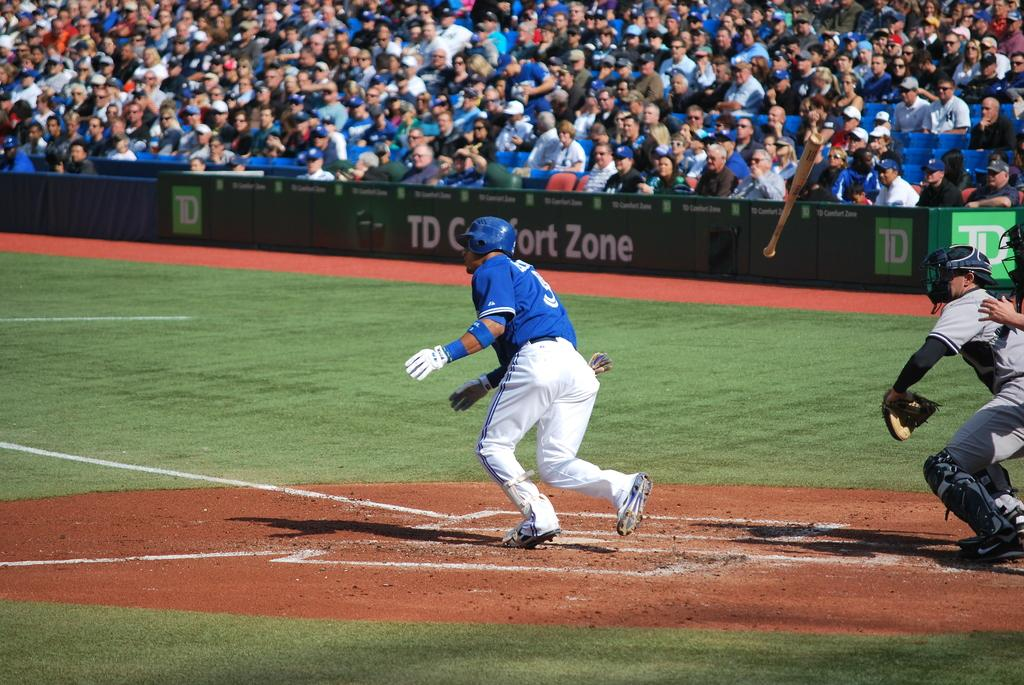Where was the image taken? The image was taken in a stadium. What are the players on the ground doing? The players are running on the ground. Can you describe the people in the background? There are spectators in the background. What type of disease is spreading among the players in the image? There is no indication of any disease in the image; the players are simply running on the ground. How much money can be seen in the image? There is no mention of money in the image; it focuses on the players and spectators in a stadium setting. 